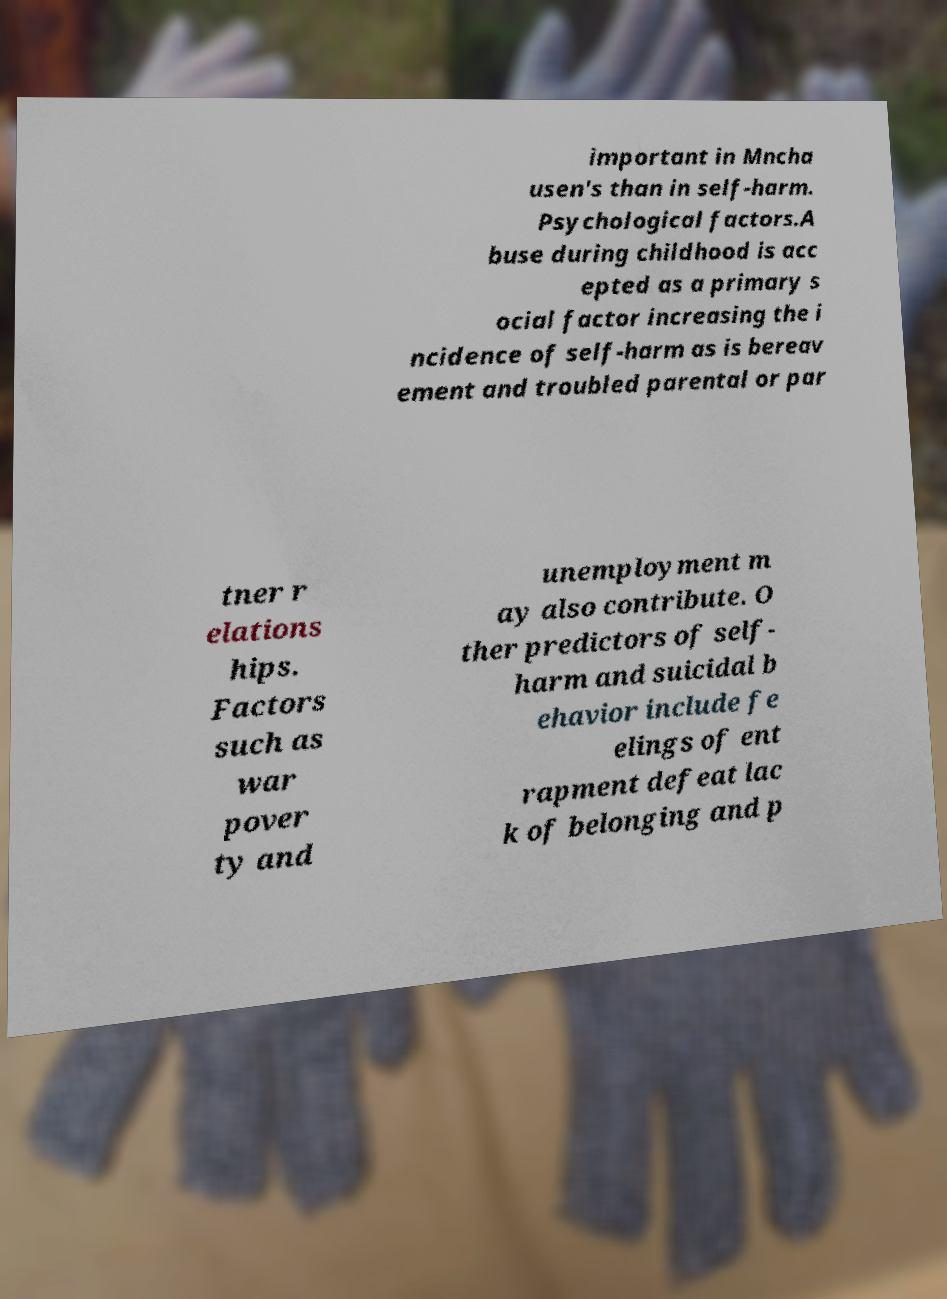What messages or text are displayed in this image? I need them in a readable, typed format. important in Mncha usen's than in self-harm. Psychological factors.A buse during childhood is acc epted as a primary s ocial factor increasing the i ncidence of self-harm as is bereav ement and troubled parental or par tner r elations hips. Factors such as war pover ty and unemployment m ay also contribute. O ther predictors of self- harm and suicidal b ehavior include fe elings of ent rapment defeat lac k of belonging and p 